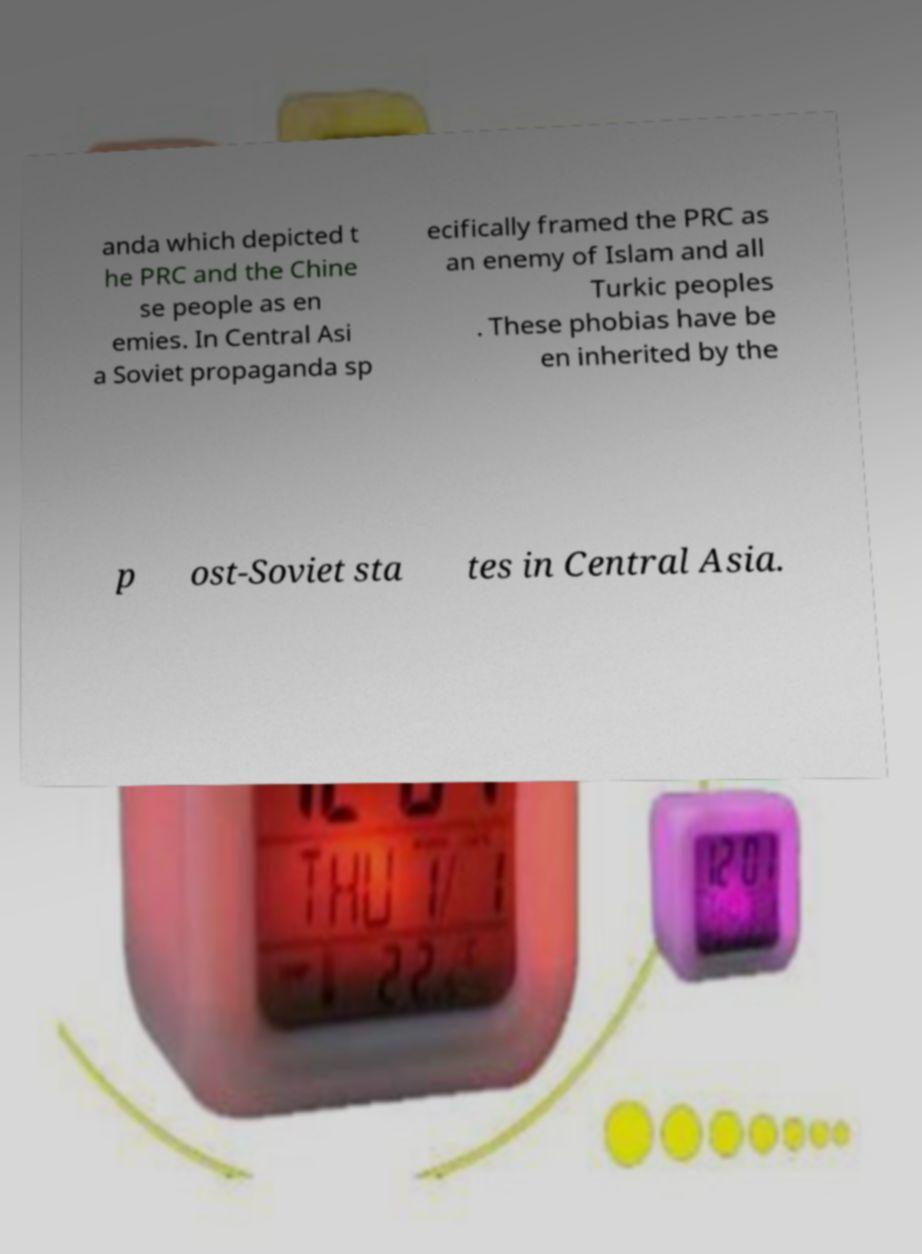Can you read and provide the text displayed in the image?This photo seems to have some interesting text. Can you extract and type it out for me? anda which depicted t he PRC and the Chine se people as en emies. In Central Asi a Soviet propaganda sp ecifically framed the PRC as an enemy of Islam and all Turkic peoples . These phobias have be en inherited by the p ost-Soviet sta tes in Central Asia. 